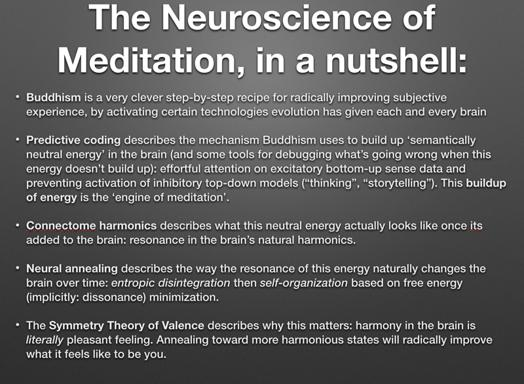What is the concept of "predictive coding" in the context of the text? Predictive coding is described in the text as a method employed by Buddhism to structure the buildup of semantically neutral energy in the brain. This concept forms part of a broader framework, intended for debugging issues that arise when this energy fails to accrue despite focused sensory attention and cognitive effort. 